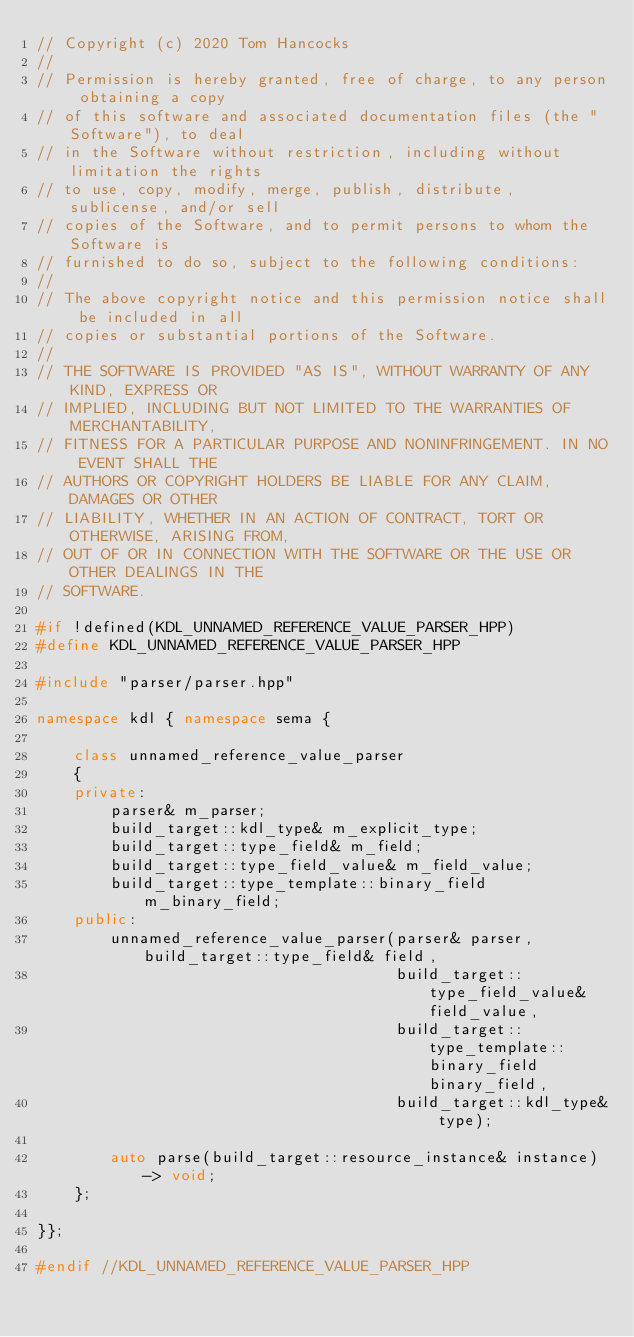<code> <loc_0><loc_0><loc_500><loc_500><_C++_>// Copyright (c) 2020 Tom Hancocks
//
// Permission is hereby granted, free of charge, to any person obtaining a copy
// of this software and associated documentation files (the "Software"), to deal
// in the Software without restriction, including without limitation the rights
// to use, copy, modify, merge, publish, distribute, sublicense, and/or sell
// copies of the Software, and to permit persons to whom the Software is
// furnished to do so, subject to the following conditions:
//
// The above copyright notice and this permission notice shall be included in all
// copies or substantial portions of the Software.
//
// THE SOFTWARE IS PROVIDED "AS IS", WITHOUT WARRANTY OF ANY KIND, EXPRESS OR
// IMPLIED, INCLUDING BUT NOT LIMITED TO THE WARRANTIES OF MERCHANTABILITY,
// FITNESS FOR A PARTICULAR PURPOSE AND NONINFRINGEMENT. IN NO EVENT SHALL THE
// AUTHORS OR COPYRIGHT HOLDERS BE LIABLE FOR ANY CLAIM, DAMAGES OR OTHER
// LIABILITY, WHETHER IN AN ACTION OF CONTRACT, TORT OR OTHERWISE, ARISING FROM,
// OUT OF OR IN CONNECTION WITH THE SOFTWARE OR THE USE OR OTHER DEALINGS IN THE
// SOFTWARE.

#if !defined(KDL_UNNAMED_REFERENCE_VALUE_PARSER_HPP)
#define KDL_UNNAMED_REFERENCE_VALUE_PARSER_HPP

#include "parser/parser.hpp"

namespace kdl { namespace sema {

    class unnamed_reference_value_parser
    {
    private:
        parser& m_parser;
        build_target::kdl_type& m_explicit_type;
        build_target::type_field& m_field;
        build_target::type_field_value& m_field_value;
        build_target::type_template::binary_field m_binary_field;
    public:
        unnamed_reference_value_parser(parser& parser, build_target::type_field& field,
                                       build_target::type_field_value& field_value,
                                       build_target::type_template::binary_field binary_field,
                                       build_target::kdl_type& type);

        auto parse(build_target::resource_instance& instance) -> void;
    };

}};

#endif //KDL_UNNAMED_REFERENCE_VALUE_PARSER_HPP
</code> 